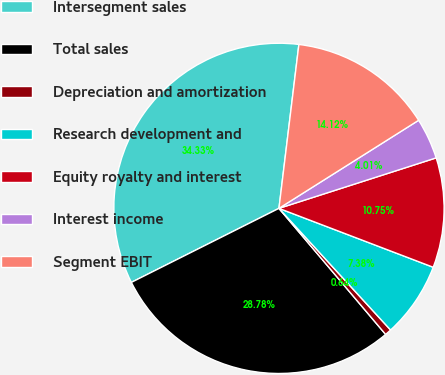Convert chart. <chart><loc_0><loc_0><loc_500><loc_500><pie_chart><fcel>Intersegment sales<fcel>Total sales<fcel>Depreciation and amortization<fcel>Research development and<fcel>Equity royalty and interest<fcel>Interest income<fcel>Segment EBIT<nl><fcel>34.33%<fcel>28.78%<fcel>0.64%<fcel>7.38%<fcel>10.75%<fcel>4.01%<fcel>14.12%<nl></chart> 